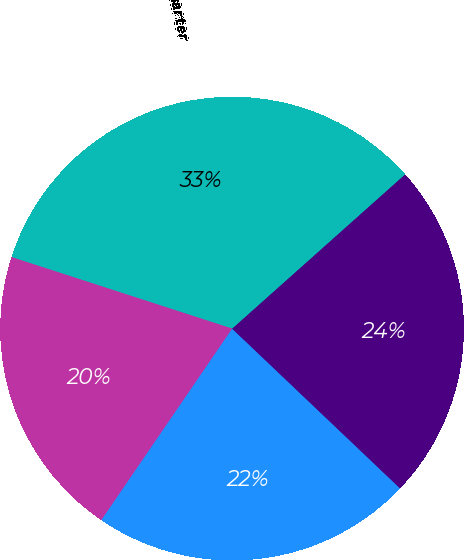<chart> <loc_0><loc_0><loc_500><loc_500><pie_chart><fcel>First Quarter<fcel>Second Quarter<fcel>Third Quarter<fcel>Fourth Quarter<nl><fcel>22.44%<fcel>23.69%<fcel>33.42%<fcel>20.45%<nl></chart> 